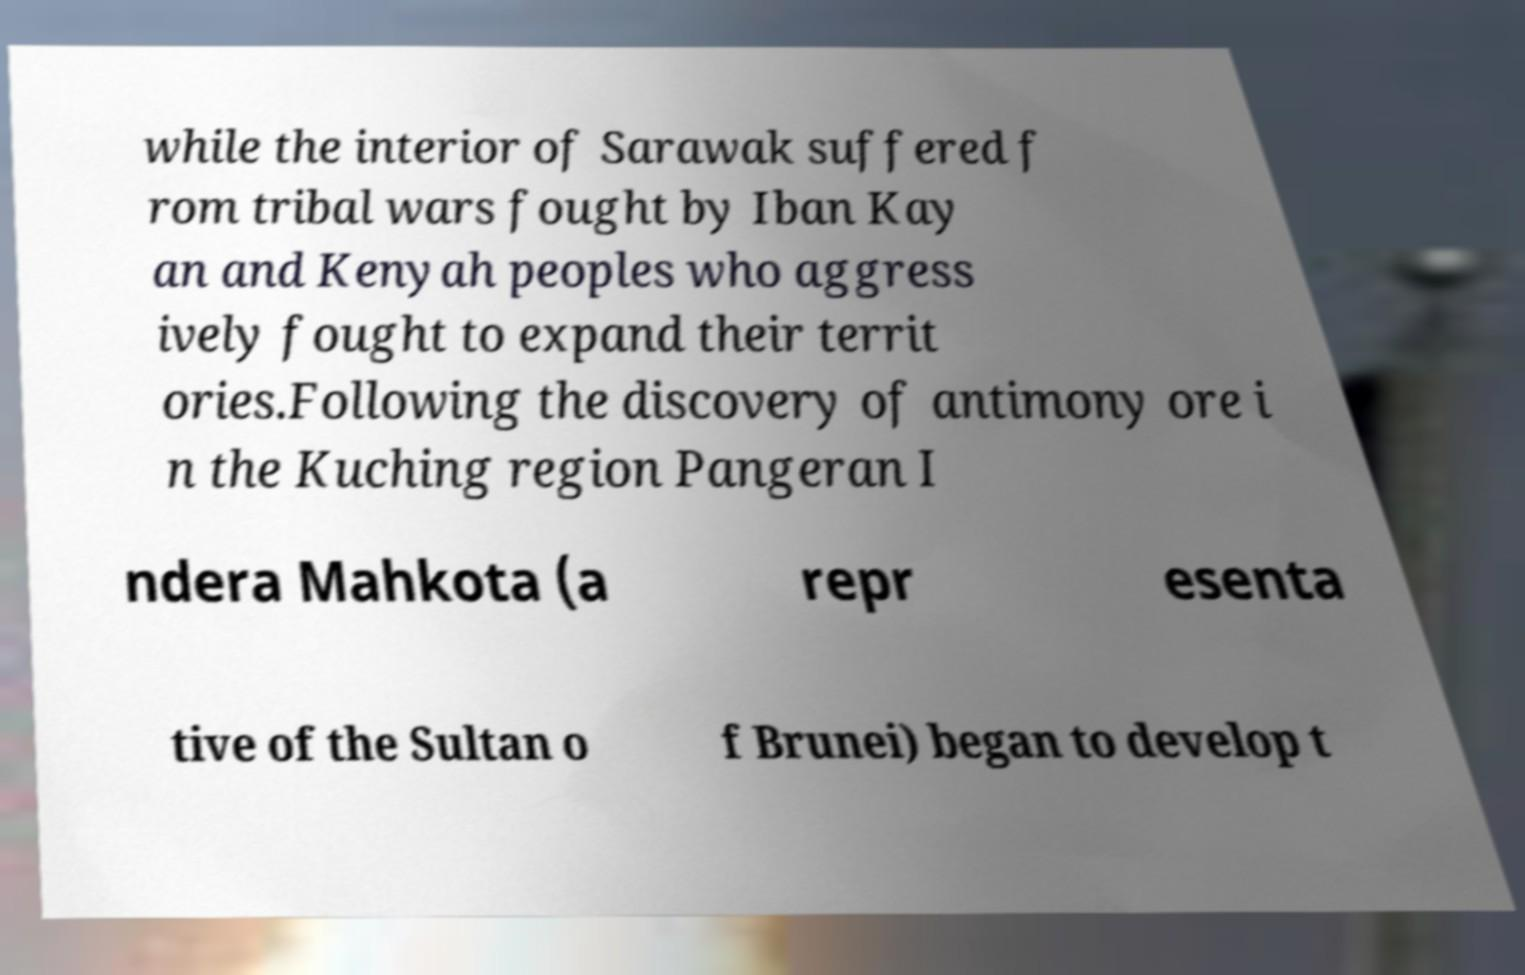Please read and relay the text visible in this image. What does it say? while the interior of Sarawak suffered f rom tribal wars fought by Iban Kay an and Kenyah peoples who aggress ively fought to expand their territ ories.Following the discovery of antimony ore i n the Kuching region Pangeran I ndera Mahkota (a repr esenta tive of the Sultan o f Brunei) began to develop t 